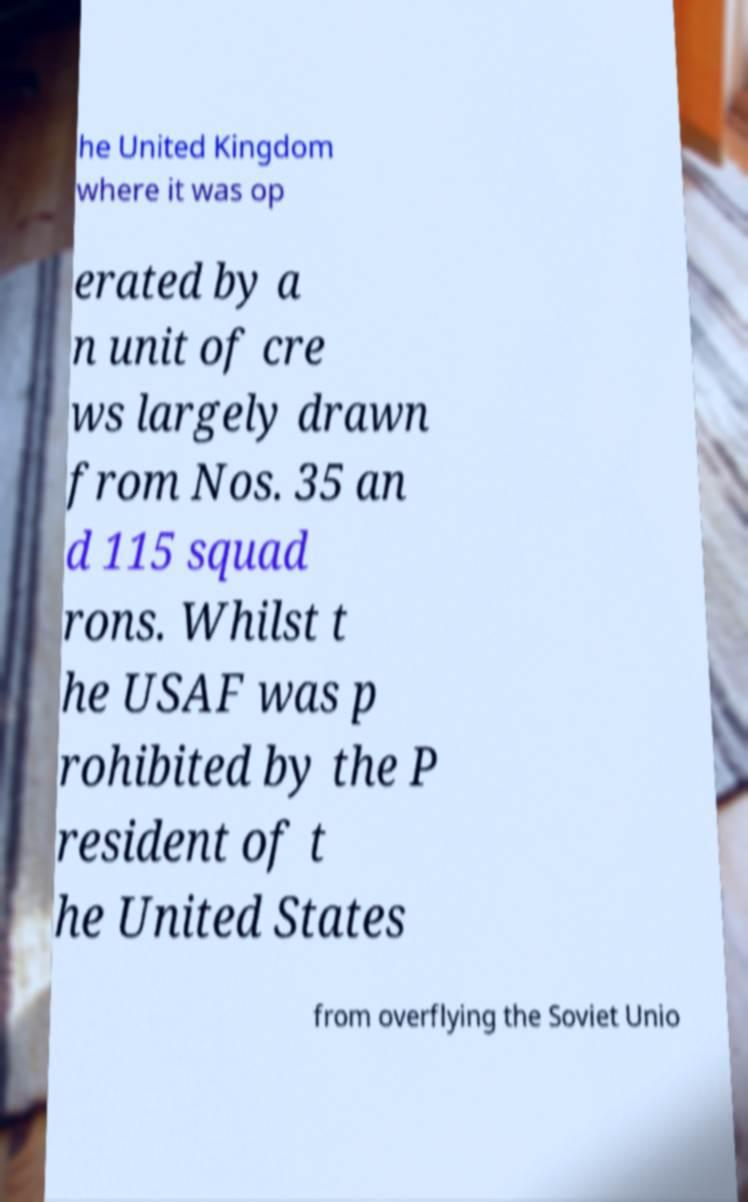I need the written content from this picture converted into text. Can you do that? he United Kingdom where it was op erated by a n unit of cre ws largely drawn from Nos. 35 an d 115 squad rons. Whilst t he USAF was p rohibited by the P resident of t he United States from overflying the Soviet Unio 